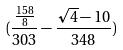<formula> <loc_0><loc_0><loc_500><loc_500>( \frac { \frac { 1 5 8 } { 8 } } { 3 0 3 } - \frac { \sqrt { 4 } - 1 0 } { 3 4 8 } )</formula> 